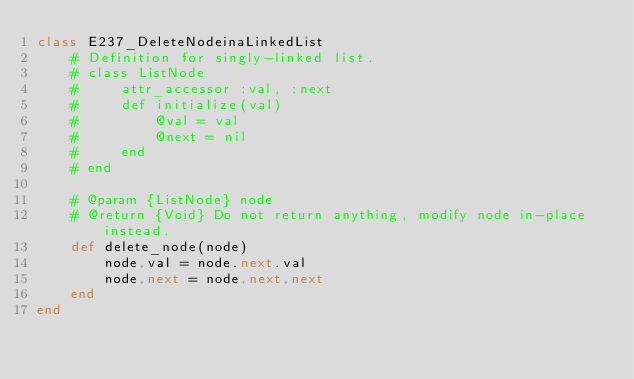Convert code to text. <code><loc_0><loc_0><loc_500><loc_500><_Ruby_>class E237_DeleteNodeinaLinkedList
    # Definition for singly-linked list.
    # class ListNode
    #     attr_accessor :val, :next
    #     def initialize(val)
    #         @val = val
    #         @next = nil
    #     end
    # end
    
    # @param {ListNode} node
    # @return {Void} Do not return anything, modify node in-place instead.
    def delete_node(node)
        node.val = node.next.val
        node.next = node.next.next
    end
end</code> 